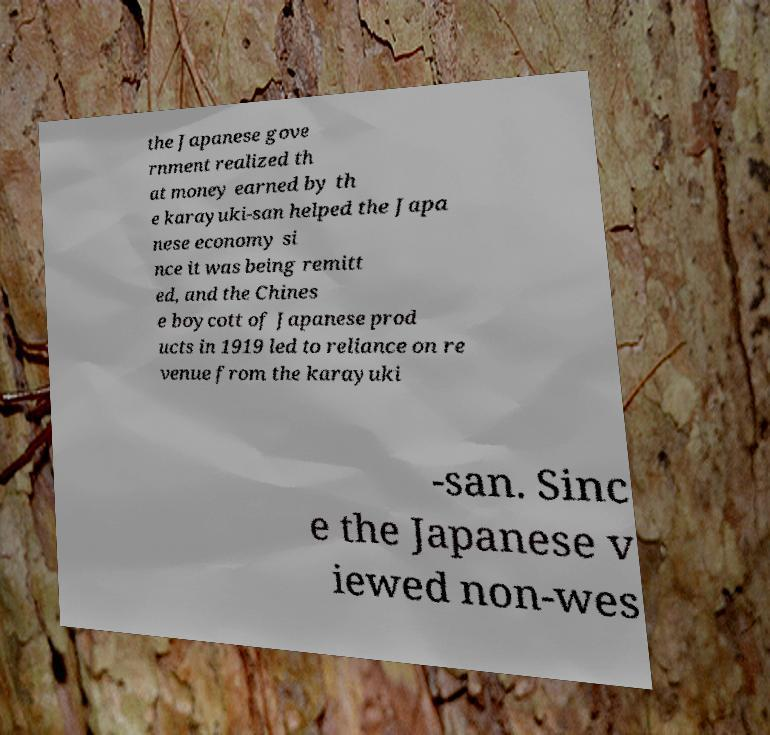Please read and relay the text visible in this image. What does it say? the Japanese gove rnment realized th at money earned by th e karayuki-san helped the Japa nese economy si nce it was being remitt ed, and the Chines e boycott of Japanese prod ucts in 1919 led to reliance on re venue from the karayuki -san. Sinc e the Japanese v iewed non-wes 